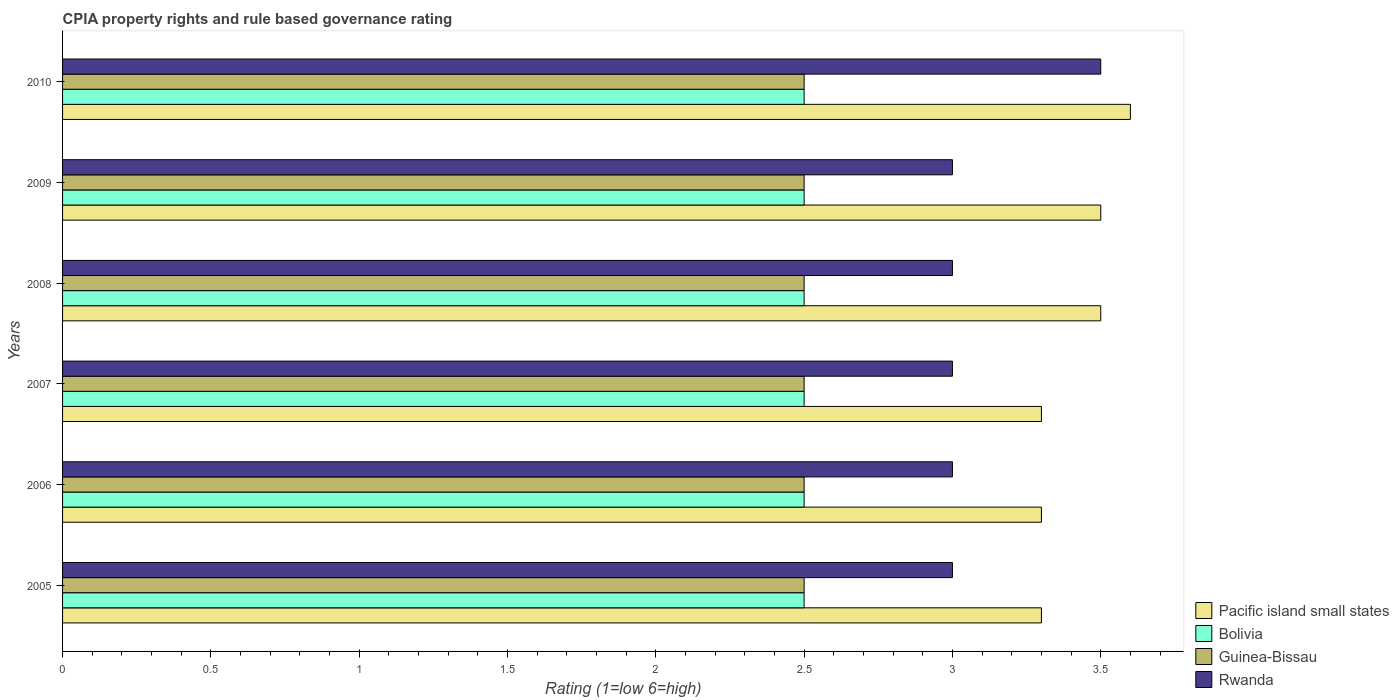How many different coloured bars are there?
Make the answer very short. 4. How many groups of bars are there?
Offer a very short reply. 6. Are the number of bars on each tick of the Y-axis equal?
Keep it short and to the point. Yes. How many bars are there on the 3rd tick from the top?
Make the answer very short. 4. What is the label of the 5th group of bars from the top?
Your answer should be very brief. 2006. In how many cases, is the number of bars for a given year not equal to the number of legend labels?
Your answer should be compact. 0. Across all years, what is the minimum CPIA rating in Bolivia?
Your answer should be compact. 2.5. In which year was the CPIA rating in Pacific island small states minimum?
Provide a succinct answer. 2005. What is the total CPIA rating in Guinea-Bissau in the graph?
Your answer should be very brief. 15. What is the difference between the CPIA rating in Rwanda in 2006 and that in 2008?
Give a very brief answer. 0. What is the difference between the CPIA rating in Pacific island small states in 2006 and the CPIA rating in Guinea-Bissau in 2009?
Ensure brevity in your answer.  0.8. In the year 2005, what is the difference between the CPIA rating in Rwanda and CPIA rating in Pacific island small states?
Provide a succinct answer. -0.3. In how many years, is the CPIA rating in Pacific island small states greater than 1.8 ?
Make the answer very short. 6. What is the difference between the highest and the second highest CPIA rating in Bolivia?
Your answer should be very brief. 0. What is the difference between the highest and the lowest CPIA rating in Bolivia?
Offer a very short reply. 0. Is the sum of the CPIA rating in Pacific island small states in 2007 and 2010 greater than the maximum CPIA rating in Guinea-Bissau across all years?
Keep it short and to the point. Yes. Is it the case that in every year, the sum of the CPIA rating in Rwanda and CPIA rating in Pacific island small states is greater than the sum of CPIA rating in Guinea-Bissau and CPIA rating in Bolivia?
Ensure brevity in your answer.  No. What does the 3rd bar from the top in 2008 represents?
Provide a short and direct response. Bolivia. What does the 1st bar from the bottom in 2005 represents?
Your answer should be compact. Pacific island small states. Is it the case that in every year, the sum of the CPIA rating in Pacific island small states and CPIA rating in Rwanda is greater than the CPIA rating in Bolivia?
Give a very brief answer. Yes. Are all the bars in the graph horizontal?
Offer a very short reply. Yes. What is the difference between two consecutive major ticks on the X-axis?
Keep it short and to the point. 0.5. Does the graph contain any zero values?
Ensure brevity in your answer.  No. Does the graph contain grids?
Offer a very short reply. No. Where does the legend appear in the graph?
Ensure brevity in your answer.  Bottom right. What is the title of the graph?
Provide a short and direct response. CPIA property rights and rule based governance rating. Does "Dominican Republic" appear as one of the legend labels in the graph?
Your answer should be compact. No. What is the label or title of the X-axis?
Ensure brevity in your answer.  Rating (1=low 6=high). What is the label or title of the Y-axis?
Keep it short and to the point. Years. What is the Rating (1=low 6=high) in Pacific island small states in 2005?
Offer a very short reply. 3.3. What is the Rating (1=low 6=high) in Guinea-Bissau in 2005?
Your answer should be compact. 2.5. What is the Rating (1=low 6=high) of Pacific island small states in 2006?
Provide a succinct answer. 3.3. What is the Rating (1=low 6=high) of Bolivia in 2006?
Provide a short and direct response. 2.5. What is the Rating (1=low 6=high) in Rwanda in 2006?
Offer a very short reply. 3. What is the Rating (1=low 6=high) of Pacific island small states in 2007?
Keep it short and to the point. 3.3. What is the Rating (1=low 6=high) in Rwanda in 2007?
Keep it short and to the point. 3. What is the Rating (1=low 6=high) in Rwanda in 2008?
Your answer should be very brief. 3. What is the Rating (1=low 6=high) in Bolivia in 2009?
Ensure brevity in your answer.  2.5. What is the Rating (1=low 6=high) in Guinea-Bissau in 2009?
Your response must be concise. 2.5. What is the Rating (1=low 6=high) in Rwanda in 2009?
Your response must be concise. 3. What is the Rating (1=low 6=high) in Bolivia in 2010?
Offer a terse response. 2.5. What is the Rating (1=low 6=high) in Rwanda in 2010?
Keep it short and to the point. 3.5. Across all years, what is the maximum Rating (1=low 6=high) of Pacific island small states?
Keep it short and to the point. 3.6. Across all years, what is the minimum Rating (1=low 6=high) in Pacific island small states?
Give a very brief answer. 3.3. Across all years, what is the minimum Rating (1=low 6=high) of Guinea-Bissau?
Provide a short and direct response. 2.5. What is the total Rating (1=low 6=high) in Pacific island small states in the graph?
Your response must be concise. 20.5. What is the total Rating (1=low 6=high) in Guinea-Bissau in the graph?
Your response must be concise. 15. What is the difference between the Rating (1=low 6=high) in Bolivia in 2005 and that in 2006?
Ensure brevity in your answer.  0. What is the difference between the Rating (1=low 6=high) in Guinea-Bissau in 2005 and that in 2006?
Your answer should be compact. 0. What is the difference between the Rating (1=low 6=high) in Pacific island small states in 2005 and that in 2008?
Give a very brief answer. -0.2. What is the difference between the Rating (1=low 6=high) in Bolivia in 2005 and that in 2008?
Your answer should be very brief. 0. What is the difference between the Rating (1=low 6=high) of Guinea-Bissau in 2005 and that in 2008?
Your answer should be very brief. 0. What is the difference between the Rating (1=low 6=high) of Pacific island small states in 2005 and that in 2009?
Offer a very short reply. -0.2. What is the difference between the Rating (1=low 6=high) of Bolivia in 2005 and that in 2009?
Provide a succinct answer. 0. What is the difference between the Rating (1=low 6=high) of Guinea-Bissau in 2006 and that in 2007?
Provide a short and direct response. 0. What is the difference between the Rating (1=low 6=high) in Rwanda in 2006 and that in 2008?
Your answer should be very brief. 0. What is the difference between the Rating (1=low 6=high) in Bolivia in 2006 and that in 2009?
Provide a succinct answer. 0. What is the difference between the Rating (1=low 6=high) of Pacific island small states in 2006 and that in 2010?
Your answer should be very brief. -0.3. What is the difference between the Rating (1=low 6=high) of Bolivia in 2006 and that in 2010?
Keep it short and to the point. 0. What is the difference between the Rating (1=low 6=high) in Guinea-Bissau in 2006 and that in 2010?
Offer a terse response. 0. What is the difference between the Rating (1=low 6=high) in Rwanda in 2006 and that in 2010?
Make the answer very short. -0.5. What is the difference between the Rating (1=low 6=high) in Pacific island small states in 2007 and that in 2008?
Give a very brief answer. -0.2. What is the difference between the Rating (1=low 6=high) in Guinea-Bissau in 2007 and that in 2008?
Give a very brief answer. 0. What is the difference between the Rating (1=low 6=high) of Rwanda in 2007 and that in 2008?
Your answer should be compact. 0. What is the difference between the Rating (1=low 6=high) of Guinea-Bissau in 2007 and that in 2009?
Your response must be concise. 0. What is the difference between the Rating (1=low 6=high) of Pacific island small states in 2007 and that in 2010?
Your answer should be compact. -0.3. What is the difference between the Rating (1=low 6=high) of Bolivia in 2007 and that in 2010?
Keep it short and to the point. 0. What is the difference between the Rating (1=low 6=high) in Guinea-Bissau in 2007 and that in 2010?
Keep it short and to the point. 0. What is the difference between the Rating (1=low 6=high) in Bolivia in 2008 and that in 2009?
Your response must be concise. 0. What is the difference between the Rating (1=low 6=high) in Pacific island small states in 2008 and that in 2010?
Offer a very short reply. -0.1. What is the difference between the Rating (1=low 6=high) in Pacific island small states in 2009 and that in 2010?
Give a very brief answer. -0.1. What is the difference between the Rating (1=low 6=high) of Guinea-Bissau in 2009 and that in 2010?
Your answer should be very brief. 0. What is the difference between the Rating (1=low 6=high) in Pacific island small states in 2005 and the Rating (1=low 6=high) in Guinea-Bissau in 2006?
Keep it short and to the point. 0.8. What is the difference between the Rating (1=low 6=high) in Pacific island small states in 2005 and the Rating (1=low 6=high) in Rwanda in 2006?
Offer a terse response. 0.3. What is the difference between the Rating (1=low 6=high) in Bolivia in 2005 and the Rating (1=low 6=high) in Rwanda in 2006?
Keep it short and to the point. -0.5. What is the difference between the Rating (1=low 6=high) of Guinea-Bissau in 2005 and the Rating (1=low 6=high) of Rwanda in 2006?
Your answer should be very brief. -0.5. What is the difference between the Rating (1=low 6=high) in Guinea-Bissau in 2005 and the Rating (1=low 6=high) in Rwanda in 2007?
Your response must be concise. -0.5. What is the difference between the Rating (1=low 6=high) in Pacific island small states in 2005 and the Rating (1=low 6=high) in Guinea-Bissau in 2008?
Offer a very short reply. 0.8. What is the difference between the Rating (1=low 6=high) of Pacific island small states in 2005 and the Rating (1=low 6=high) of Rwanda in 2008?
Keep it short and to the point. 0.3. What is the difference between the Rating (1=low 6=high) in Bolivia in 2005 and the Rating (1=low 6=high) in Guinea-Bissau in 2008?
Provide a short and direct response. 0. What is the difference between the Rating (1=low 6=high) of Guinea-Bissau in 2005 and the Rating (1=low 6=high) of Rwanda in 2008?
Your response must be concise. -0.5. What is the difference between the Rating (1=low 6=high) in Bolivia in 2005 and the Rating (1=low 6=high) in Guinea-Bissau in 2009?
Give a very brief answer. 0. What is the difference between the Rating (1=low 6=high) of Bolivia in 2005 and the Rating (1=low 6=high) of Rwanda in 2009?
Keep it short and to the point. -0.5. What is the difference between the Rating (1=low 6=high) of Pacific island small states in 2005 and the Rating (1=low 6=high) of Bolivia in 2010?
Provide a short and direct response. 0.8. What is the difference between the Rating (1=low 6=high) of Pacific island small states in 2005 and the Rating (1=low 6=high) of Guinea-Bissau in 2010?
Offer a terse response. 0.8. What is the difference between the Rating (1=low 6=high) in Pacific island small states in 2005 and the Rating (1=low 6=high) in Rwanda in 2010?
Provide a short and direct response. -0.2. What is the difference between the Rating (1=low 6=high) in Pacific island small states in 2006 and the Rating (1=low 6=high) in Bolivia in 2007?
Offer a terse response. 0.8. What is the difference between the Rating (1=low 6=high) in Pacific island small states in 2006 and the Rating (1=low 6=high) in Guinea-Bissau in 2007?
Your answer should be compact. 0.8. What is the difference between the Rating (1=low 6=high) of Pacific island small states in 2006 and the Rating (1=low 6=high) of Bolivia in 2008?
Ensure brevity in your answer.  0.8. What is the difference between the Rating (1=low 6=high) of Pacific island small states in 2006 and the Rating (1=low 6=high) of Rwanda in 2008?
Your answer should be very brief. 0.3. What is the difference between the Rating (1=low 6=high) of Guinea-Bissau in 2006 and the Rating (1=low 6=high) of Rwanda in 2008?
Your response must be concise. -0.5. What is the difference between the Rating (1=low 6=high) of Pacific island small states in 2006 and the Rating (1=low 6=high) of Guinea-Bissau in 2009?
Offer a very short reply. 0.8. What is the difference between the Rating (1=low 6=high) in Bolivia in 2006 and the Rating (1=low 6=high) in Guinea-Bissau in 2010?
Ensure brevity in your answer.  0. What is the difference between the Rating (1=low 6=high) in Bolivia in 2006 and the Rating (1=low 6=high) in Rwanda in 2010?
Provide a short and direct response. -1. What is the difference between the Rating (1=low 6=high) of Pacific island small states in 2007 and the Rating (1=low 6=high) of Guinea-Bissau in 2008?
Provide a short and direct response. 0.8. What is the difference between the Rating (1=low 6=high) of Pacific island small states in 2007 and the Rating (1=low 6=high) of Rwanda in 2008?
Make the answer very short. 0.3. What is the difference between the Rating (1=low 6=high) in Bolivia in 2007 and the Rating (1=low 6=high) in Rwanda in 2008?
Keep it short and to the point. -0.5. What is the difference between the Rating (1=low 6=high) of Guinea-Bissau in 2007 and the Rating (1=low 6=high) of Rwanda in 2008?
Your answer should be very brief. -0.5. What is the difference between the Rating (1=low 6=high) of Pacific island small states in 2007 and the Rating (1=low 6=high) of Guinea-Bissau in 2009?
Keep it short and to the point. 0.8. What is the difference between the Rating (1=low 6=high) of Pacific island small states in 2007 and the Rating (1=low 6=high) of Rwanda in 2009?
Give a very brief answer. 0.3. What is the difference between the Rating (1=low 6=high) in Bolivia in 2007 and the Rating (1=low 6=high) in Guinea-Bissau in 2009?
Offer a very short reply. 0. What is the difference between the Rating (1=low 6=high) of Guinea-Bissau in 2007 and the Rating (1=low 6=high) of Rwanda in 2009?
Offer a very short reply. -0.5. What is the difference between the Rating (1=low 6=high) in Pacific island small states in 2007 and the Rating (1=low 6=high) in Rwanda in 2010?
Your response must be concise. -0.2. What is the difference between the Rating (1=low 6=high) in Bolivia in 2007 and the Rating (1=low 6=high) in Rwanda in 2010?
Offer a terse response. -1. What is the difference between the Rating (1=low 6=high) of Guinea-Bissau in 2007 and the Rating (1=low 6=high) of Rwanda in 2010?
Provide a succinct answer. -1. What is the difference between the Rating (1=low 6=high) of Pacific island small states in 2008 and the Rating (1=low 6=high) of Bolivia in 2009?
Your answer should be compact. 1. What is the difference between the Rating (1=low 6=high) of Pacific island small states in 2008 and the Rating (1=low 6=high) of Rwanda in 2009?
Provide a succinct answer. 0.5. What is the difference between the Rating (1=low 6=high) in Pacific island small states in 2008 and the Rating (1=low 6=high) in Guinea-Bissau in 2010?
Keep it short and to the point. 1. What is the difference between the Rating (1=low 6=high) in Pacific island small states in 2008 and the Rating (1=low 6=high) in Rwanda in 2010?
Keep it short and to the point. 0. What is the difference between the Rating (1=low 6=high) of Bolivia in 2008 and the Rating (1=low 6=high) of Guinea-Bissau in 2010?
Your answer should be very brief. 0. What is the difference between the Rating (1=low 6=high) of Bolivia in 2008 and the Rating (1=low 6=high) of Rwanda in 2010?
Offer a terse response. -1. What is the difference between the Rating (1=low 6=high) of Guinea-Bissau in 2008 and the Rating (1=low 6=high) of Rwanda in 2010?
Your answer should be compact. -1. What is the difference between the Rating (1=low 6=high) of Pacific island small states in 2009 and the Rating (1=low 6=high) of Bolivia in 2010?
Provide a short and direct response. 1. What is the difference between the Rating (1=low 6=high) in Pacific island small states in 2009 and the Rating (1=low 6=high) in Rwanda in 2010?
Provide a succinct answer. 0. What is the difference between the Rating (1=low 6=high) in Bolivia in 2009 and the Rating (1=low 6=high) in Guinea-Bissau in 2010?
Keep it short and to the point. 0. What is the difference between the Rating (1=low 6=high) of Bolivia in 2009 and the Rating (1=low 6=high) of Rwanda in 2010?
Make the answer very short. -1. What is the average Rating (1=low 6=high) of Pacific island small states per year?
Offer a terse response. 3.42. What is the average Rating (1=low 6=high) in Bolivia per year?
Provide a short and direct response. 2.5. What is the average Rating (1=low 6=high) in Guinea-Bissau per year?
Provide a short and direct response. 2.5. What is the average Rating (1=low 6=high) of Rwanda per year?
Keep it short and to the point. 3.08. In the year 2005, what is the difference between the Rating (1=low 6=high) of Pacific island small states and Rating (1=low 6=high) of Bolivia?
Keep it short and to the point. 0.8. In the year 2005, what is the difference between the Rating (1=low 6=high) of Pacific island small states and Rating (1=low 6=high) of Guinea-Bissau?
Your answer should be compact. 0.8. In the year 2005, what is the difference between the Rating (1=low 6=high) in Pacific island small states and Rating (1=low 6=high) in Rwanda?
Your answer should be compact. 0.3. In the year 2005, what is the difference between the Rating (1=low 6=high) in Bolivia and Rating (1=low 6=high) in Guinea-Bissau?
Provide a succinct answer. 0. In the year 2007, what is the difference between the Rating (1=low 6=high) of Pacific island small states and Rating (1=low 6=high) of Bolivia?
Make the answer very short. 0.8. In the year 2007, what is the difference between the Rating (1=low 6=high) in Bolivia and Rating (1=low 6=high) in Guinea-Bissau?
Keep it short and to the point. 0. In the year 2007, what is the difference between the Rating (1=low 6=high) in Bolivia and Rating (1=low 6=high) in Rwanda?
Provide a succinct answer. -0.5. In the year 2008, what is the difference between the Rating (1=low 6=high) in Bolivia and Rating (1=low 6=high) in Rwanda?
Offer a very short reply. -0.5. In the year 2008, what is the difference between the Rating (1=low 6=high) of Guinea-Bissau and Rating (1=low 6=high) of Rwanda?
Make the answer very short. -0.5. In the year 2009, what is the difference between the Rating (1=low 6=high) in Pacific island small states and Rating (1=low 6=high) in Guinea-Bissau?
Keep it short and to the point. 1. In the year 2009, what is the difference between the Rating (1=low 6=high) of Pacific island small states and Rating (1=low 6=high) of Rwanda?
Make the answer very short. 0.5. In the year 2009, what is the difference between the Rating (1=low 6=high) in Bolivia and Rating (1=low 6=high) in Rwanda?
Give a very brief answer. -0.5. In the year 2009, what is the difference between the Rating (1=low 6=high) of Guinea-Bissau and Rating (1=low 6=high) of Rwanda?
Offer a terse response. -0.5. In the year 2010, what is the difference between the Rating (1=low 6=high) in Bolivia and Rating (1=low 6=high) in Rwanda?
Give a very brief answer. -1. In the year 2010, what is the difference between the Rating (1=low 6=high) in Guinea-Bissau and Rating (1=low 6=high) in Rwanda?
Offer a terse response. -1. What is the ratio of the Rating (1=low 6=high) in Pacific island small states in 2005 to that in 2006?
Your response must be concise. 1. What is the ratio of the Rating (1=low 6=high) of Bolivia in 2005 to that in 2006?
Keep it short and to the point. 1. What is the ratio of the Rating (1=low 6=high) of Pacific island small states in 2005 to that in 2008?
Your response must be concise. 0.94. What is the ratio of the Rating (1=low 6=high) of Pacific island small states in 2005 to that in 2009?
Your answer should be very brief. 0.94. What is the ratio of the Rating (1=low 6=high) in Rwanda in 2005 to that in 2009?
Ensure brevity in your answer.  1. What is the ratio of the Rating (1=low 6=high) of Bolivia in 2005 to that in 2010?
Keep it short and to the point. 1. What is the ratio of the Rating (1=low 6=high) in Guinea-Bissau in 2005 to that in 2010?
Your answer should be very brief. 1. What is the ratio of the Rating (1=low 6=high) in Bolivia in 2006 to that in 2007?
Offer a terse response. 1. What is the ratio of the Rating (1=low 6=high) of Rwanda in 2006 to that in 2007?
Provide a short and direct response. 1. What is the ratio of the Rating (1=low 6=high) of Pacific island small states in 2006 to that in 2008?
Provide a succinct answer. 0.94. What is the ratio of the Rating (1=low 6=high) of Bolivia in 2006 to that in 2008?
Keep it short and to the point. 1. What is the ratio of the Rating (1=low 6=high) in Guinea-Bissau in 2006 to that in 2008?
Keep it short and to the point. 1. What is the ratio of the Rating (1=low 6=high) in Pacific island small states in 2006 to that in 2009?
Ensure brevity in your answer.  0.94. What is the ratio of the Rating (1=low 6=high) of Bolivia in 2006 to that in 2009?
Keep it short and to the point. 1. What is the ratio of the Rating (1=low 6=high) of Guinea-Bissau in 2006 to that in 2009?
Your response must be concise. 1. What is the ratio of the Rating (1=low 6=high) in Rwanda in 2006 to that in 2009?
Your answer should be compact. 1. What is the ratio of the Rating (1=low 6=high) in Rwanda in 2006 to that in 2010?
Your answer should be compact. 0.86. What is the ratio of the Rating (1=low 6=high) in Pacific island small states in 2007 to that in 2008?
Your response must be concise. 0.94. What is the ratio of the Rating (1=low 6=high) of Bolivia in 2007 to that in 2008?
Your response must be concise. 1. What is the ratio of the Rating (1=low 6=high) of Pacific island small states in 2007 to that in 2009?
Your response must be concise. 0.94. What is the ratio of the Rating (1=low 6=high) in Guinea-Bissau in 2007 to that in 2009?
Make the answer very short. 1. What is the ratio of the Rating (1=low 6=high) of Pacific island small states in 2007 to that in 2010?
Provide a short and direct response. 0.92. What is the ratio of the Rating (1=low 6=high) in Rwanda in 2007 to that in 2010?
Your answer should be compact. 0.86. What is the ratio of the Rating (1=low 6=high) in Pacific island small states in 2008 to that in 2009?
Provide a succinct answer. 1. What is the ratio of the Rating (1=low 6=high) of Guinea-Bissau in 2008 to that in 2009?
Offer a very short reply. 1. What is the ratio of the Rating (1=low 6=high) in Pacific island small states in 2008 to that in 2010?
Your answer should be very brief. 0.97. What is the ratio of the Rating (1=low 6=high) in Bolivia in 2008 to that in 2010?
Keep it short and to the point. 1. What is the ratio of the Rating (1=low 6=high) of Pacific island small states in 2009 to that in 2010?
Ensure brevity in your answer.  0.97. What is the ratio of the Rating (1=low 6=high) of Bolivia in 2009 to that in 2010?
Offer a terse response. 1. What is the ratio of the Rating (1=low 6=high) in Guinea-Bissau in 2009 to that in 2010?
Your response must be concise. 1. What is the ratio of the Rating (1=low 6=high) in Rwanda in 2009 to that in 2010?
Your response must be concise. 0.86. What is the difference between the highest and the second highest Rating (1=low 6=high) in Pacific island small states?
Your response must be concise. 0.1. What is the difference between the highest and the second highest Rating (1=low 6=high) in Guinea-Bissau?
Your answer should be compact. 0. What is the difference between the highest and the second highest Rating (1=low 6=high) of Rwanda?
Make the answer very short. 0.5. What is the difference between the highest and the lowest Rating (1=low 6=high) in Pacific island small states?
Offer a very short reply. 0.3. What is the difference between the highest and the lowest Rating (1=low 6=high) of Bolivia?
Make the answer very short. 0. What is the difference between the highest and the lowest Rating (1=low 6=high) in Rwanda?
Ensure brevity in your answer.  0.5. 